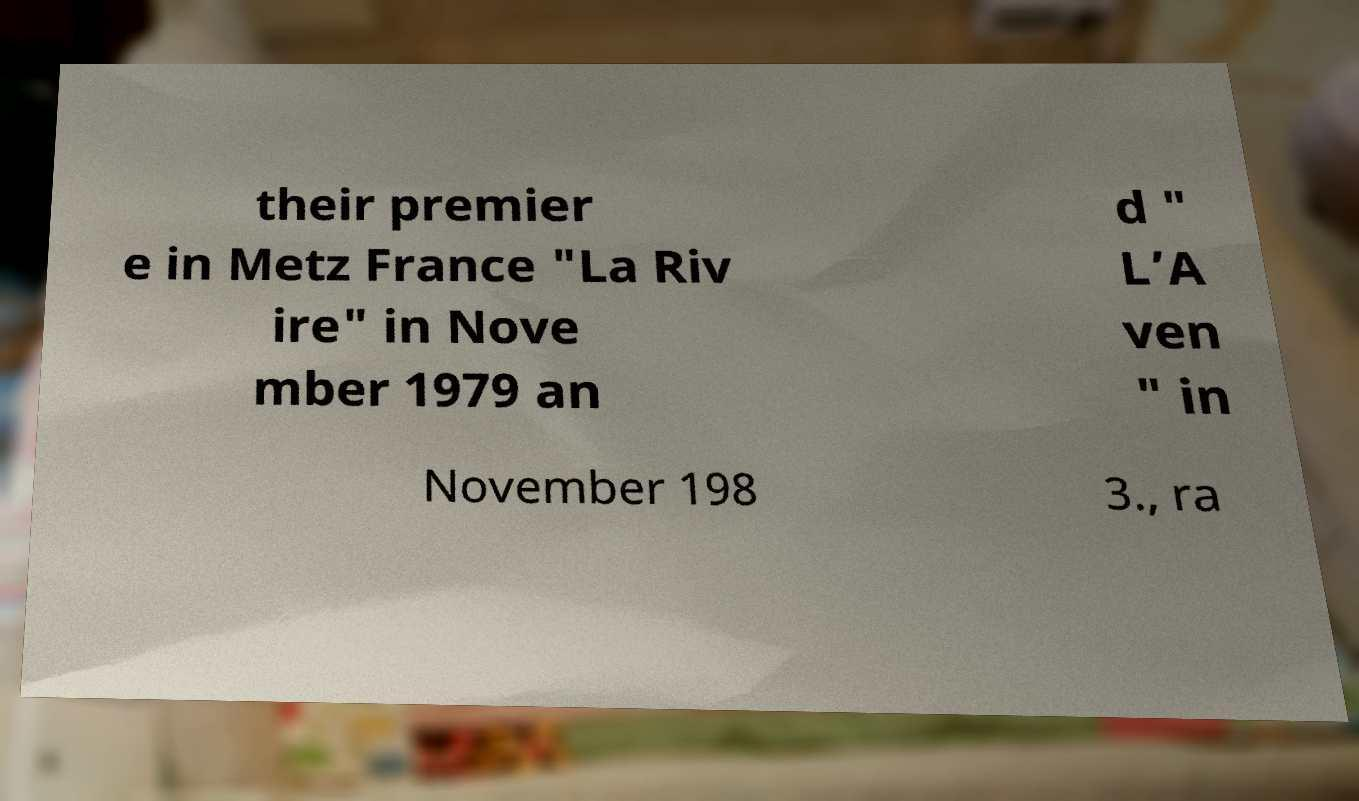There's text embedded in this image that I need extracted. Can you transcribe it verbatim? their premier e in Metz France "La Riv ire" in Nove mber 1979 an d " L’A ven " in November 198 3., ra 